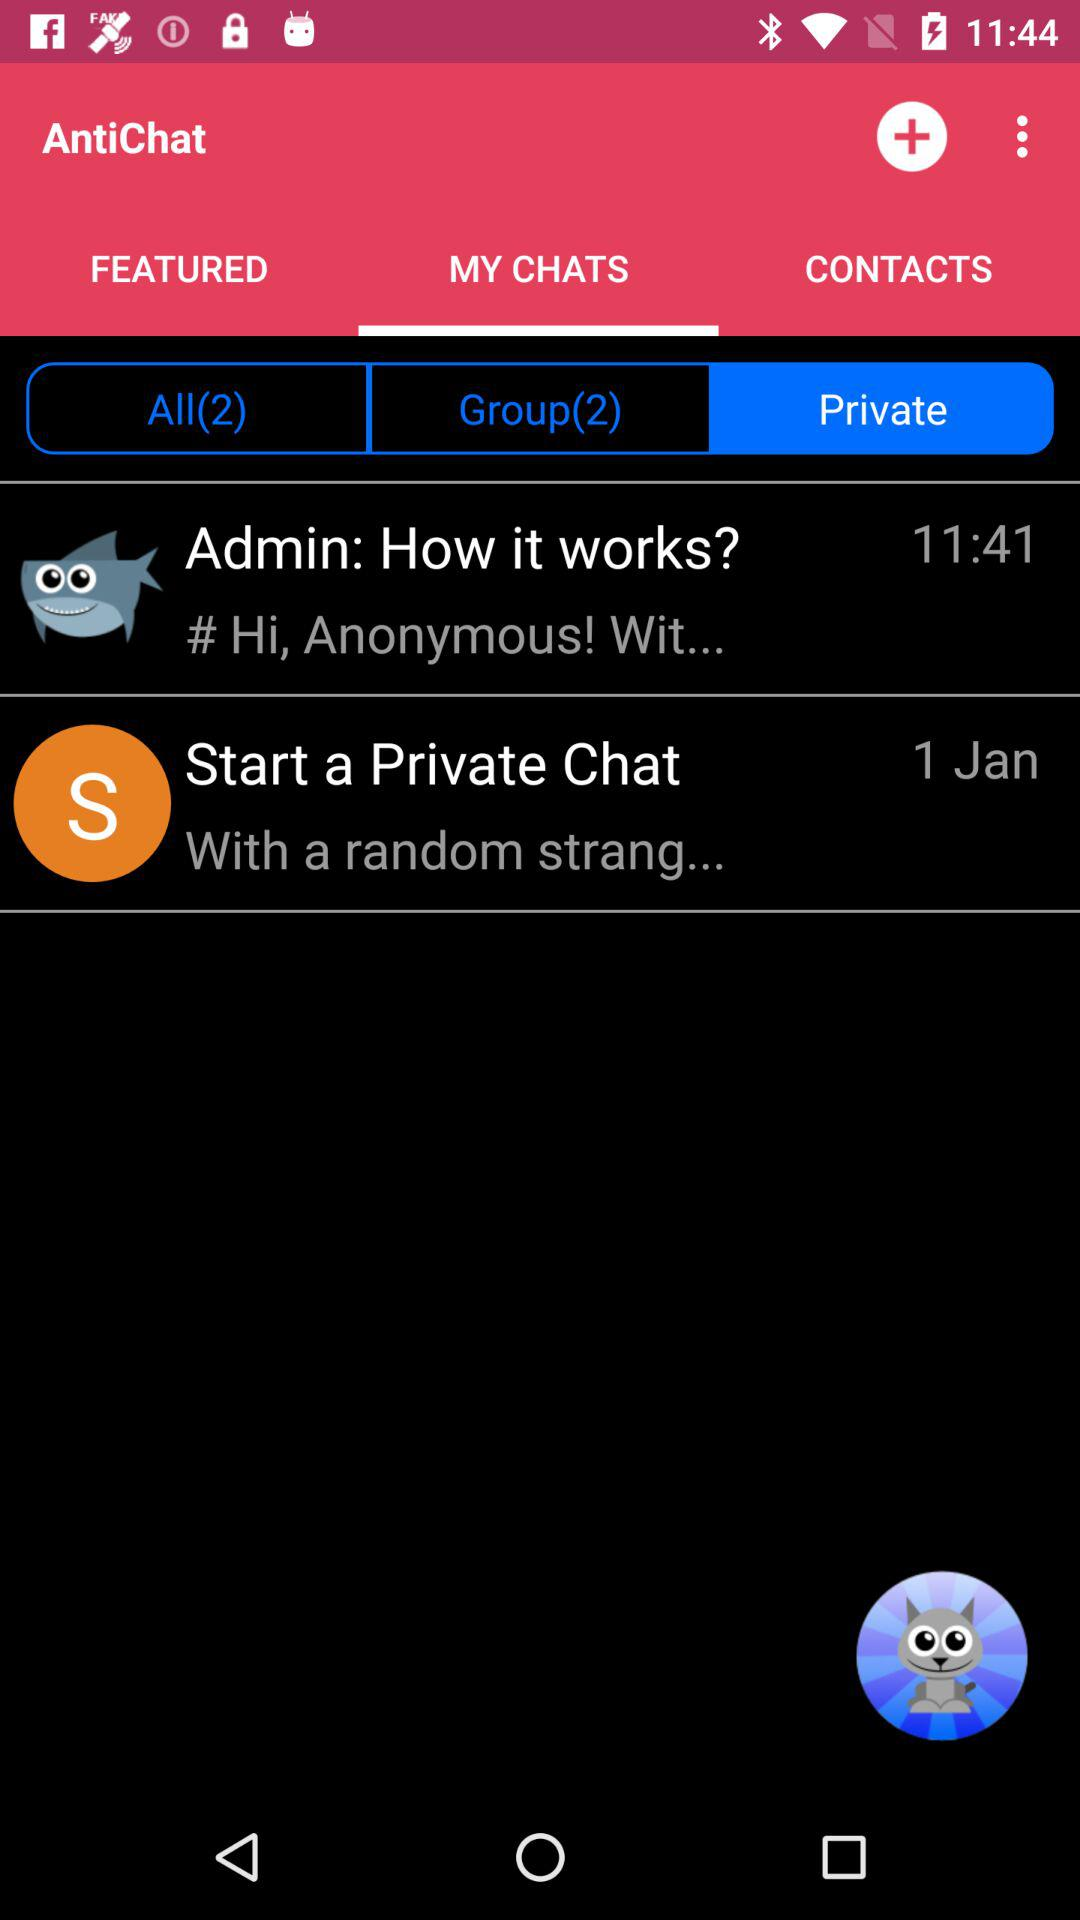How many groups are there? There are 2 groups. 